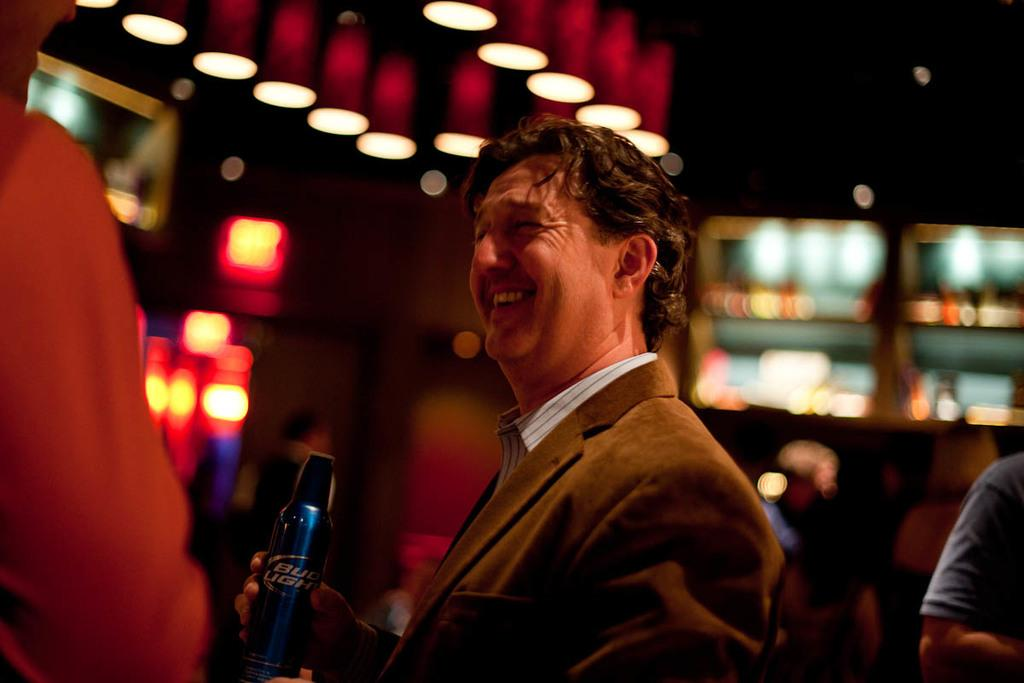What is the main subject of the image? There is a person standing in the image. What is the person holding in his hand? The person is holding a bottle in his hand. What can be seen in the image besides the person? There are lights visible in the image. Can you describe the background of the image? The background of the image is blurry. How many cakes are being carried by the snails in the image? There are no snails or cakes present in the image. What type of pest is causing damage to the person's clothing in the image? There is no pest visible in the image, and the person's clothing appears undamaged. 